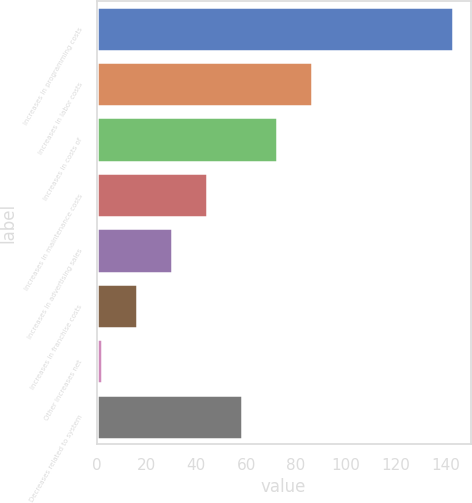Convert chart. <chart><loc_0><loc_0><loc_500><loc_500><bar_chart><fcel>Increases in programming costs<fcel>Increases in labor costs<fcel>Increases in costs of<fcel>Increases in maintenance costs<fcel>Increases in advertising sales<fcel>Increases in franchise costs<fcel>Other increases net<fcel>Decreases related to system<nl><fcel>143<fcel>86.6<fcel>72.5<fcel>44.3<fcel>30.2<fcel>16.1<fcel>2<fcel>58.4<nl></chart> 